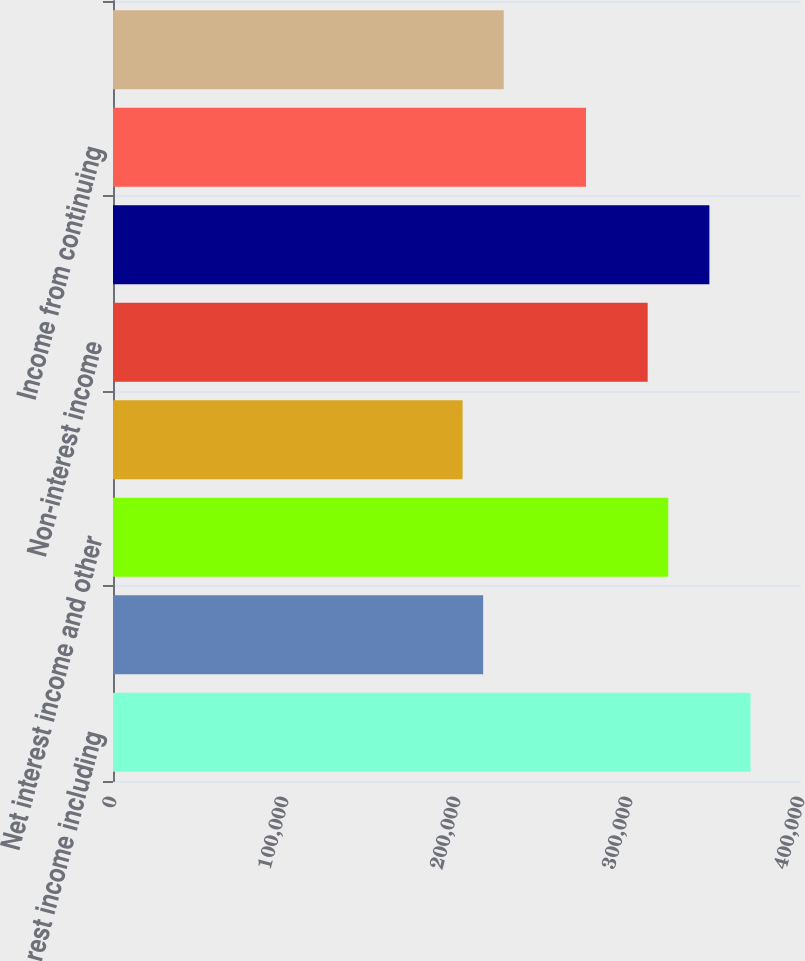Convert chart to OTSL. <chart><loc_0><loc_0><loc_500><loc_500><bar_chart><fcel>Interest income including<fcel>Interest expense and<fcel>Net interest income and other<fcel>Provision for loan losses<fcel>Non-interest income<fcel>Non-interest expense<fcel>Income from continuing<fcel>Income tax expense<nl><fcel>370644<fcel>215213<fcel>322819<fcel>203257<fcel>310862<fcel>346731<fcel>274994<fcel>227169<nl></chart> 